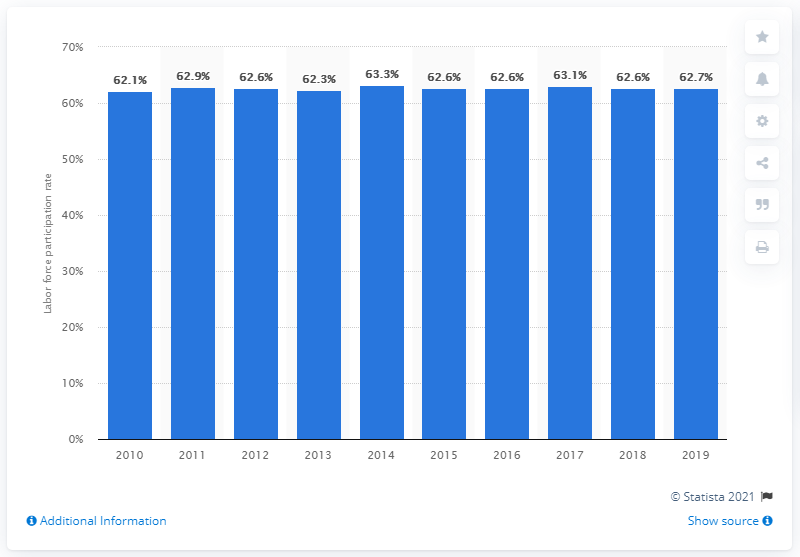Identify some key points in this picture. In 2019, the labor force participation rate in Seoul, South Korea was 62.7%. 